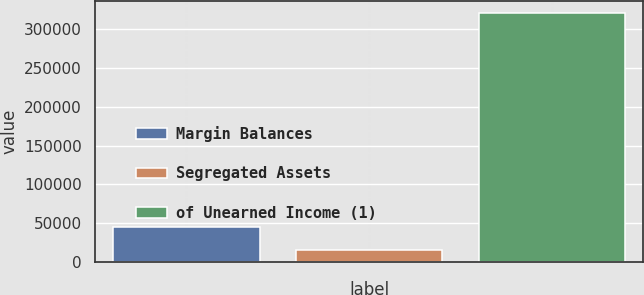Convert chart. <chart><loc_0><loc_0><loc_500><loc_500><bar_chart><fcel>Margin Balances<fcel>Segregated Assets<fcel>of Unearned Income (1)<nl><fcel>45324.1<fcel>14786<fcel>320167<nl></chart> 